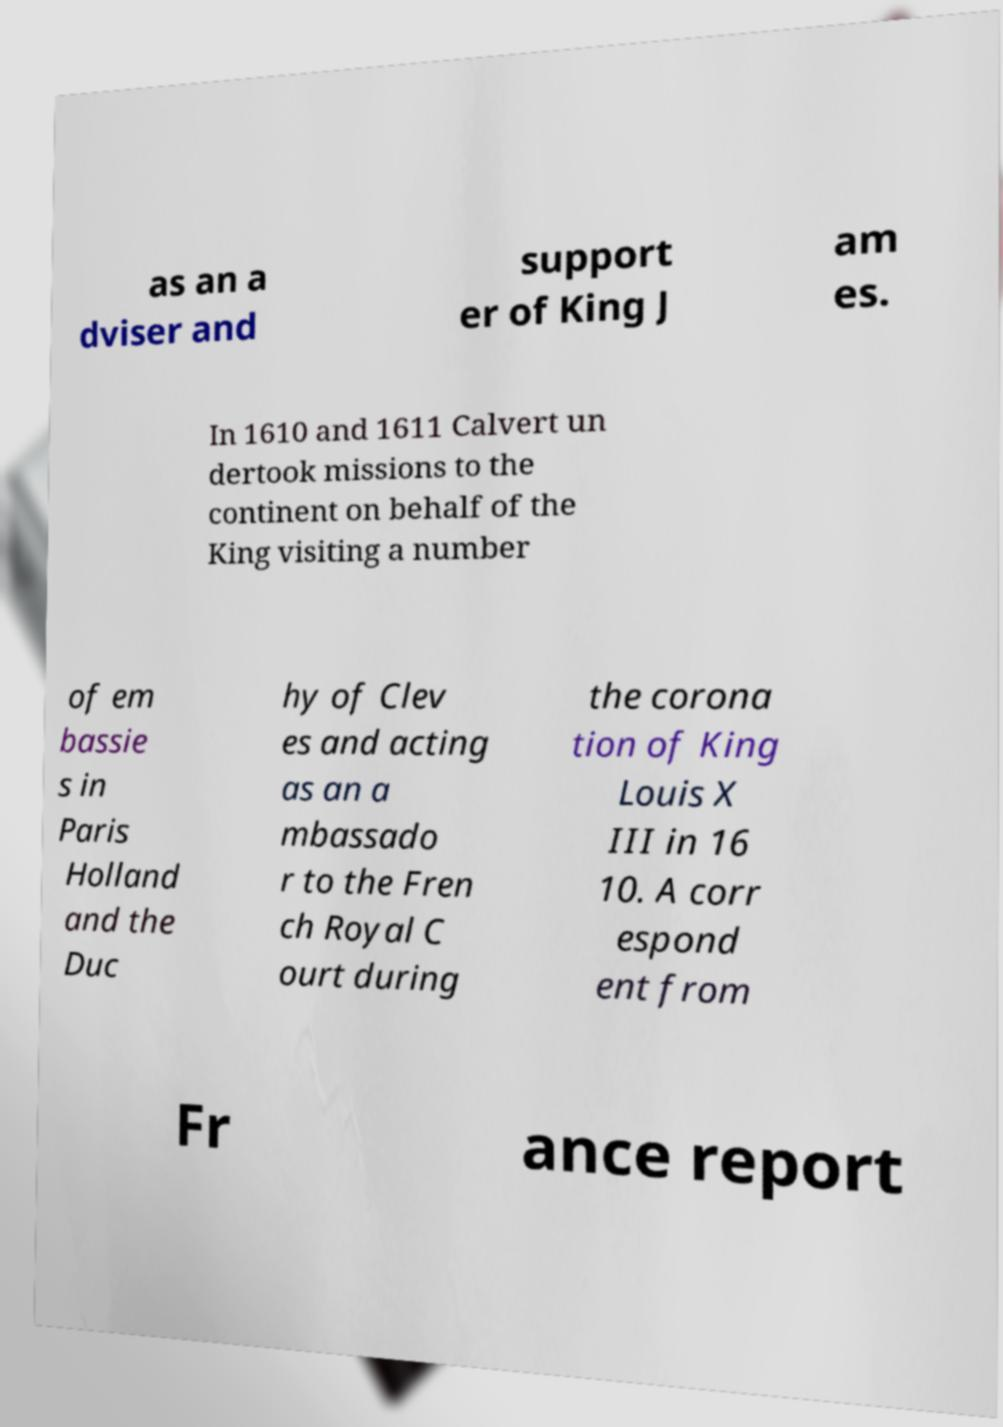I need the written content from this picture converted into text. Can you do that? as an a dviser and support er of King J am es. In 1610 and 1611 Calvert un dertook missions to the continent on behalf of the King visiting a number of em bassie s in Paris Holland and the Duc hy of Clev es and acting as an a mbassado r to the Fren ch Royal C ourt during the corona tion of King Louis X III in 16 10. A corr espond ent from Fr ance report 